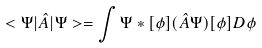<formula> <loc_0><loc_0><loc_500><loc_500>< \Psi | \hat { A } | \Psi > = \int \Psi * [ \phi ] ( \hat { A } \Psi ) [ \phi ] D \phi</formula> 